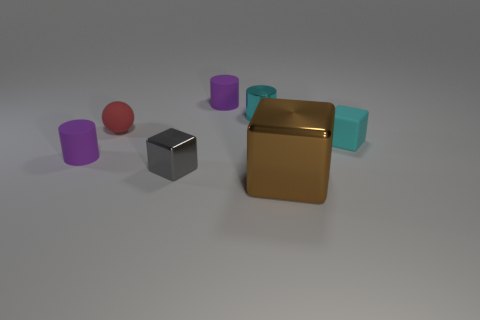Add 2 cyan things. How many objects exist? 9 Subtract all blocks. How many objects are left? 4 Add 2 gray shiny things. How many gray shiny things exist? 3 Subtract 0 blue cylinders. How many objects are left? 7 Subtract all cyan cylinders. Subtract all small gray shiny cubes. How many objects are left? 5 Add 4 purple cylinders. How many purple cylinders are left? 6 